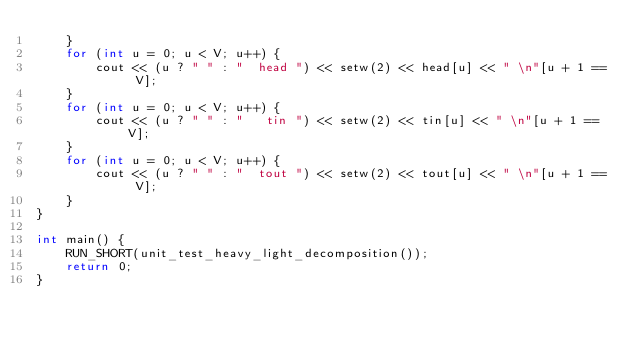Convert code to text. <code><loc_0><loc_0><loc_500><loc_500><_C++_>    }
    for (int u = 0; u < V; u++) {
        cout << (u ? " " : "  head ") << setw(2) << head[u] << " \n"[u + 1 == V];
    }
    for (int u = 0; u < V; u++) {
        cout << (u ? " " : "   tin ") << setw(2) << tin[u] << " \n"[u + 1 == V];
    }
    for (int u = 0; u < V; u++) {
        cout << (u ? " " : "  tout ") << setw(2) << tout[u] << " \n"[u + 1 == V];
    }
}

int main() {
    RUN_SHORT(unit_test_heavy_light_decomposition());
    return 0;
}
</code> 